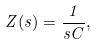Convert formula to latex. <formula><loc_0><loc_0><loc_500><loc_500>Z ( s ) = { \frac { 1 } { s C } } ,</formula> 